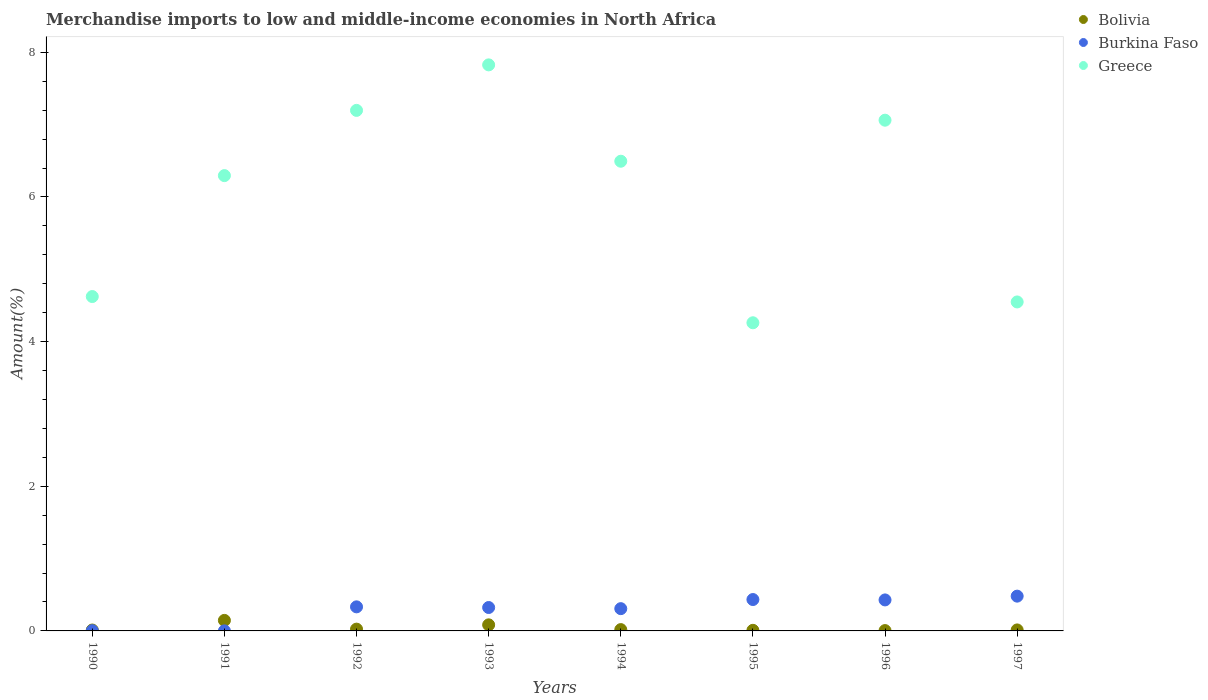How many different coloured dotlines are there?
Your answer should be compact. 3. What is the percentage of amount earned from merchandise imports in Burkina Faso in 1992?
Your answer should be compact. 0.33. Across all years, what is the maximum percentage of amount earned from merchandise imports in Bolivia?
Make the answer very short. 0.15. Across all years, what is the minimum percentage of amount earned from merchandise imports in Burkina Faso?
Make the answer very short. 0. In which year was the percentage of amount earned from merchandise imports in Burkina Faso maximum?
Offer a terse response. 1997. What is the total percentage of amount earned from merchandise imports in Burkina Faso in the graph?
Offer a terse response. 2.31. What is the difference between the percentage of amount earned from merchandise imports in Greece in 1994 and that in 1997?
Your response must be concise. 1.95. What is the difference between the percentage of amount earned from merchandise imports in Burkina Faso in 1992 and the percentage of amount earned from merchandise imports in Greece in 1997?
Give a very brief answer. -4.22. What is the average percentage of amount earned from merchandise imports in Greece per year?
Offer a very short reply. 6.04. In the year 1990, what is the difference between the percentage of amount earned from merchandise imports in Greece and percentage of amount earned from merchandise imports in Bolivia?
Give a very brief answer. 4.61. In how many years, is the percentage of amount earned from merchandise imports in Burkina Faso greater than 4.8 %?
Provide a succinct answer. 0. What is the ratio of the percentage of amount earned from merchandise imports in Bolivia in 1991 to that in 1996?
Your answer should be very brief. 30.61. Is the percentage of amount earned from merchandise imports in Greece in 1996 less than that in 1997?
Your answer should be very brief. No. Is the difference between the percentage of amount earned from merchandise imports in Greece in 1990 and 1997 greater than the difference between the percentage of amount earned from merchandise imports in Bolivia in 1990 and 1997?
Provide a short and direct response. Yes. What is the difference between the highest and the second highest percentage of amount earned from merchandise imports in Burkina Faso?
Provide a succinct answer. 0.05. What is the difference between the highest and the lowest percentage of amount earned from merchandise imports in Burkina Faso?
Provide a short and direct response. 0.48. Does the percentage of amount earned from merchandise imports in Greece monotonically increase over the years?
Your answer should be very brief. No. Is the percentage of amount earned from merchandise imports in Greece strictly greater than the percentage of amount earned from merchandise imports in Burkina Faso over the years?
Give a very brief answer. Yes. How many dotlines are there?
Provide a short and direct response. 3. How many years are there in the graph?
Ensure brevity in your answer.  8. Are the values on the major ticks of Y-axis written in scientific E-notation?
Offer a terse response. No. Does the graph contain any zero values?
Provide a succinct answer. No. Where does the legend appear in the graph?
Offer a terse response. Top right. How are the legend labels stacked?
Your answer should be compact. Vertical. What is the title of the graph?
Your answer should be very brief. Merchandise imports to low and middle-income economies in North Africa. What is the label or title of the Y-axis?
Your answer should be compact. Amount(%). What is the Amount(%) of Bolivia in 1990?
Offer a terse response. 0.01. What is the Amount(%) of Burkina Faso in 1990?
Keep it short and to the point. 0. What is the Amount(%) in Greece in 1990?
Offer a terse response. 4.62. What is the Amount(%) of Bolivia in 1991?
Keep it short and to the point. 0.15. What is the Amount(%) of Burkina Faso in 1991?
Provide a short and direct response. 0. What is the Amount(%) in Greece in 1991?
Your answer should be compact. 6.3. What is the Amount(%) of Bolivia in 1992?
Your response must be concise. 0.02. What is the Amount(%) in Burkina Faso in 1992?
Provide a short and direct response. 0.33. What is the Amount(%) in Greece in 1992?
Provide a succinct answer. 7.2. What is the Amount(%) in Bolivia in 1993?
Offer a very short reply. 0.08. What is the Amount(%) of Burkina Faso in 1993?
Your answer should be compact. 0.32. What is the Amount(%) of Greece in 1993?
Offer a very short reply. 7.83. What is the Amount(%) of Bolivia in 1994?
Offer a terse response. 0.02. What is the Amount(%) of Burkina Faso in 1994?
Offer a very short reply. 0.31. What is the Amount(%) in Greece in 1994?
Give a very brief answer. 6.49. What is the Amount(%) of Bolivia in 1995?
Ensure brevity in your answer.  0.01. What is the Amount(%) in Burkina Faso in 1995?
Make the answer very short. 0.43. What is the Amount(%) in Greece in 1995?
Make the answer very short. 4.26. What is the Amount(%) in Bolivia in 1996?
Keep it short and to the point. 0. What is the Amount(%) of Burkina Faso in 1996?
Provide a succinct answer. 0.43. What is the Amount(%) of Greece in 1996?
Provide a short and direct response. 7.06. What is the Amount(%) of Bolivia in 1997?
Provide a short and direct response. 0.01. What is the Amount(%) in Burkina Faso in 1997?
Offer a very short reply. 0.48. What is the Amount(%) in Greece in 1997?
Your answer should be compact. 4.55. Across all years, what is the maximum Amount(%) in Bolivia?
Your answer should be compact. 0.15. Across all years, what is the maximum Amount(%) of Burkina Faso?
Provide a succinct answer. 0.48. Across all years, what is the maximum Amount(%) of Greece?
Give a very brief answer. 7.83. Across all years, what is the minimum Amount(%) in Bolivia?
Keep it short and to the point. 0. Across all years, what is the minimum Amount(%) in Burkina Faso?
Your response must be concise. 0. Across all years, what is the minimum Amount(%) in Greece?
Provide a short and direct response. 4.26. What is the total Amount(%) in Bolivia in the graph?
Your response must be concise. 0.31. What is the total Amount(%) in Burkina Faso in the graph?
Provide a short and direct response. 2.31. What is the total Amount(%) in Greece in the graph?
Offer a terse response. 48.31. What is the difference between the Amount(%) of Bolivia in 1990 and that in 1991?
Offer a terse response. -0.13. What is the difference between the Amount(%) of Burkina Faso in 1990 and that in 1991?
Make the answer very short. 0. What is the difference between the Amount(%) of Greece in 1990 and that in 1991?
Provide a succinct answer. -1.67. What is the difference between the Amount(%) in Bolivia in 1990 and that in 1992?
Provide a short and direct response. -0.01. What is the difference between the Amount(%) of Burkina Faso in 1990 and that in 1992?
Your response must be concise. -0.33. What is the difference between the Amount(%) of Greece in 1990 and that in 1992?
Your answer should be very brief. -2.57. What is the difference between the Amount(%) of Bolivia in 1990 and that in 1993?
Keep it short and to the point. -0.07. What is the difference between the Amount(%) in Burkina Faso in 1990 and that in 1993?
Your answer should be very brief. -0.32. What is the difference between the Amount(%) of Greece in 1990 and that in 1993?
Keep it short and to the point. -3.2. What is the difference between the Amount(%) of Bolivia in 1990 and that in 1994?
Offer a very short reply. -0.01. What is the difference between the Amount(%) in Burkina Faso in 1990 and that in 1994?
Your answer should be very brief. -0.3. What is the difference between the Amount(%) of Greece in 1990 and that in 1994?
Make the answer very short. -1.87. What is the difference between the Amount(%) of Bolivia in 1990 and that in 1995?
Your answer should be very brief. 0. What is the difference between the Amount(%) in Burkina Faso in 1990 and that in 1995?
Your answer should be very brief. -0.43. What is the difference between the Amount(%) in Greece in 1990 and that in 1995?
Your answer should be very brief. 0.36. What is the difference between the Amount(%) in Bolivia in 1990 and that in 1996?
Provide a short and direct response. 0.01. What is the difference between the Amount(%) in Burkina Faso in 1990 and that in 1996?
Provide a short and direct response. -0.43. What is the difference between the Amount(%) in Greece in 1990 and that in 1996?
Your answer should be compact. -2.44. What is the difference between the Amount(%) in Bolivia in 1990 and that in 1997?
Keep it short and to the point. -0. What is the difference between the Amount(%) of Burkina Faso in 1990 and that in 1997?
Provide a short and direct response. -0.48. What is the difference between the Amount(%) of Greece in 1990 and that in 1997?
Offer a terse response. 0.07. What is the difference between the Amount(%) of Bolivia in 1991 and that in 1992?
Your answer should be very brief. 0.12. What is the difference between the Amount(%) in Burkina Faso in 1991 and that in 1992?
Offer a terse response. -0.33. What is the difference between the Amount(%) of Greece in 1991 and that in 1992?
Keep it short and to the point. -0.9. What is the difference between the Amount(%) of Bolivia in 1991 and that in 1993?
Your response must be concise. 0.06. What is the difference between the Amount(%) in Burkina Faso in 1991 and that in 1993?
Your answer should be compact. -0.32. What is the difference between the Amount(%) in Greece in 1991 and that in 1993?
Your answer should be very brief. -1.53. What is the difference between the Amount(%) in Bolivia in 1991 and that in 1994?
Your response must be concise. 0.13. What is the difference between the Amount(%) of Burkina Faso in 1991 and that in 1994?
Offer a very short reply. -0.31. What is the difference between the Amount(%) of Greece in 1991 and that in 1994?
Provide a short and direct response. -0.2. What is the difference between the Amount(%) in Bolivia in 1991 and that in 1995?
Keep it short and to the point. 0.14. What is the difference between the Amount(%) in Burkina Faso in 1991 and that in 1995?
Offer a very short reply. -0.43. What is the difference between the Amount(%) of Greece in 1991 and that in 1995?
Ensure brevity in your answer.  2.03. What is the difference between the Amount(%) in Bolivia in 1991 and that in 1996?
Keep it short and to the point. 0.14. What is the difference between the Amount(%) in Burkina Faso in 1991 and that in 1996?
Offer a very short reply. -0.43. What is the difference between the Amount(%) in Greece in 1991 and that in 1996?
Provide a succinct answer. -0.77. What is the difference between the Amount(%) in Bolivia in 1991 and that in 1997?
Your answer should be very brief. 0.13. What is the difference between the Amount(%) in Burkina Faso in 1991 and that in 1997?
Your response must be concise. -0.48. What is the difference between the Amount(%) of Greece in 1991 and that in 1997?
Offer a terse response. 1.75. What is the difference between the Amount(%) in Bolivia in 1992 and that in 1993?
Offer a terse response. -0.06. What is the difference between the Amount(%) in Burkina Faso in 1992 and that in 1993?
Offer a terse response. 0.01. What is the difference between the Amount(%) of Greece in 1992 and that in 1993?
Give a very brief answer. -0.63. What is the difference between the Amount(%) of Bolivia in 1992 and that in 1994?
Offer a terse response. 0.01. What is the difference between the Amount(%) in Burkina Faso in 1992 and that in 1994?
Your answer should be very brief. 0.02. What is the difference between the Amount(%) in Greece in 1992 and that in 1994?
Make the answer very short. 0.7. What is the difference between the Amount(%) of Bolivia in 1992 and that in 1995?
Give a very brief answer. 0.02. What is the difference between the Amount(%) of Burkina Faso in 1992 and that in 1995?
Your response must be concise. -0.1. What is the difference between the Amount(%) of Greece in 1992 and that in 1995?
Offer a very short reply. 2.94. What is the difference between the Amount(%) in Burkina Faso in 1992 and that in 1996?
Your response must be concise. -0.1. What is the difference between the Amount(%) of Greece in 1992 and that in 1996?
Your response must be concise. 0.14. What is the difference between the Amount(%) of Bolivia in 1992 and that in 1997?
Provide a succinct answer. 0.01. What is the difference between the Amount(%) of Burkina Faso in 1992 and that in 1997?
Give a very brief answer. -0.15. What is the difference between the Amount(%) in Greece in 1992 and that in 1997?
Offer a very short reply. 2.65. What is the difference between the Amount(%) of Bolivia in 1993 and that in 1994?
Keep it short and to the point. 0.07. What is the difference between the Amount(%) of Burkina Faso in 1993 and that in 1994?
Offer a very short reply. 0.02. What is the difference between the Amount(%) in Greece in 1993 and that in 1994?
Offer a very short reply. 1.33. What is the difference between the Amount(%) in Bolivia in 1993 and that in 1995?
Provide a short and direct response. 0.08. What is the difference between the Amount(%) of Burkina Faso in 1993 and that in 1995?
Make the answer very short. -0.11. What is the difference between the Amount(%) in Greece in 1993 and that in 1995?
Give a very brief answer. 3.57. What is the difference between the Amount(%) of Bolivia in 1993 and that in 1996?
Give a very brief answer. 0.08. What is the difference between the Amount(%) in Burkina Faso in 1993 and that in 1996?
Your response must be concise. -0.1. What is the difference between the Amount(%) of Greece in 1993 and that in 1996?
Give a very brief answer. 0.76. What is the difference between the Amount(%) of Bolivia in 1993 and that in 1997?
Ensure brevity in your answer.  0.07. What is the difference between the Amount(%) in Burkina Faso in 1993 and that in 1997?
Keep it short and to the point. -0.16. What is the difference between the Amount(%) in Greece in 1993 and that in 1997?
Your response must be concise. 3.28. What is the difference between the Amount(%) in Bolivia in 1994 and that in 1995?
Your response must be concise. 0.01. What is the difference between the Amount(%) in Burkina Faso in 1994 and that in 1995?
Give a very brief answer. -0.13. What is the difference between the Amount(%) of Greece in 1994 and that in 1995?
Give a very brief answer. 2.23. What is the difference between the Amount(%) in Bolivia in 1994 and that in 1996?
Provide a succinct answer. 0.01. What is the difference between the Amount(%) of Burkina Faso in 1994 and that in 1996?
Provide a succinct answer. -0.12. What is the difference between the Amount(%) in Greece in 1994 and that in 1996?
Provide a short and direct response. -0.57. What is the difference between the Amount(%) in Bolivia in 1994 and that in 1997?
Keep it short and to the point. 0. What is the difference between the Amount(%) in Burkina Faso in 1994 and that in 1997?
Offer a terse response. -0.17. What is the difference between the Amount(%) of Greece in 1994 and that in 1997?
Your answer should be compact. 1.95. What is the difference between the Amount(%) of Bolivia in 1995 and that in 1996?
Offer a terse response. 0. What is the difference between the Amount(%) of Burkina Faso in 1995 and that in 1996?
Your answer should be compact. 0.01. What is the difference between the Amount(%) in Greece in 1995 and that in 1996?
Offer a very short reply. -2.8. What is the difference between the Amount(%) in Bolivia in 1995 and that in 1997?
Make the answer very short. -0.01. What is the difference between the Amount(%) in Burkina Faso in 1995 and that in 1997?
Your response must be concise. -0.05. What is the difference between the Amount(%) of Greece in 1995 and that in 1997?
Keep it short and to the point. -0.29. What is the difference between the Amount(%) in Bolivia in 1996 and that in 1997?
Your response must be concise. -0.01. What is the difference between the Amount(%) in Burkina Faso in 1996 and that in 1997?
Your answer should be very brief. -0.05. What is the difference between the Amount(%) in Greece in 1996 and that in 1997?
Provide a short and direct response. 2.51. What is the difference between the Amount(%) in Bolivia in 1990 and the Amount(%) in Burkina Faso in 1991?
Provide a short and direct response. 0.01. What is the difference between the Amount(%) of Bolivia in 1990 and the Amount(%) of Greece in 1991?
Offer a very short reply. -6.28. What is the difference between the Amount(%) in Burkina Faso in 1990 and the Amount(%) in Greece in 1991?
Provide a succinct answer. -6.29. What is the difference between the Amount(%) of Bolivia in 1990 and the Amount(%) of Burkina Faso in 1992?
Your answer should be very brief. -0.32. What is the difference between the Amount(%) in Bolivia in 1990 and the Amount(%) in Greece in 1992?
Provide a short and direct response. -7.18. What is the difference between the Amount(%) in Burkina Faso in 1990 and the Amount(%) in Greece in 1992?
Your answer should be compact. -7.19. What is the difference between the Amount(%) of Bolivia in 1990 and the Amount(%) of Burkina Faso in 1993?
Make the answer very short. -0.31. What is the difference between the Amount(%) in Bolivia in 1990 and the Amount(%) in Greece in 1993?
Ensure brevity in your answer.  -7.81. What is the difference between the Amount(%) in Burkina Faso in 1990 and the Amount(%) in Greece in 1993?
Provide a short and direct response. -7.82. What is the difference between the Amount(%) of Bolivia in 1990 and the Amount(%) of Burkina Faso in 1994?
Your answer should be compact. -0.3. What is the difference between the Amount(%) in Bolivia in 1990 and the Amount(%) in Greece in 1994?
Your response must be concise. -6.48. What is the difference between the Amount(%) in Burkina Faso in 1990 and the Amount(%) in Greece in 1994?
Provide a succinct answer. -6.49. What is the difference between the Amount(%) of Bolivia in 1990 and the Amount(%) of Burkina Faso in 1995?
Provide a succinct answer. -0.42. What is the difference between the Amount(%) of Bolivia in 1990 and the Amount(%) of Greece in 1995?
Make the answer very short. -4.25. What is the difference between the Amount(%) of Burkina Faso in 1990 and the Amount(%) of Greece in 1995?
Give a very brief answer. -4.26. What is the difference between the Amount(%) in Bolivia in 1990 and the Amount(%) in Burkina Faso in 1996?
Offer a terse response. -0.42. What is the difference between the Amount(%) of Bolivia in 1990 and the Amount(%) of Greece in 1996?
Offer a terse response. -7.05. What is the difference between the Amount(%) of Burkina Faso in 1990 and the Amount(%) of Greece in 1996?
Keep it short and to the point. -7.06. What is the difference between the Amount(%) in Bolivia in 1990 and the Amount(%) in Burkina Faso in 1997?
Give a very brief answer. -0.47. What is the difference between the Amount(%) in Bolivia in 1990 and the Amount(%) in Greece in 1997?
Offer a terse response. -4.54. What is the difference between the Amount(%) in Burkina Faso in 1990 and the Amount(%) in Greece in 1997?
Offer a very short reply. -4.54. What is the difference between the Amount(%) in Bolivia in 1991 and the Amount(%) in Burkina Faso in 1992?
Offer a terse response. -0.19. What is the difference between the Amount(%) of Bolivia in 1991 and the Amount(%) of Greece in 1992?
Your response must be concise. -7.05. What is the difference between the Amount(%) in Burkina Faso in 1991 and the Amount(%) in Greece in 1992?
Make the answer very short. -7.2. What is the difference between the Amount(%) in Bolivia in 1991 and the Amount(%) in Burkina Faso in 1993?
Offer a terse response. -0.18. What is the difference between the Amount(%) of Bolivia in 1991 and the Amount(%) of Greece in 1993?
Keep it short and to the point. -7.68. What is the difference between the Amount(%) of Burkina Faso in 1991 and the Amount(%) of Greece in 1993?
Give a very brief answer. -7.83. What is the difference between the Amount(%) of Bolivia in 1991 and the Amount(%) of Burkina Faso in 1994?
Provide a short and direct response. -0.16. What is the difference between the Amount(%) of Bolivia in 1991 and the Amount(%) of Greece in 1994?
Provide a short and direct response. -6.35. What is the difference between the Amount(%) of Burkina Faso in 1991 and the Amount(%) of Greece in 1994?
Make the answer very short. -6.49. What is the difference between the Amount(%) in Bolivia in 1991 and the Amount(%) in Burkina Faso in 1995?
Offer a terse response. -0.29. What is the difference between the Amount(%) of Bolivia in 1991 and the Amount(%) of Greece in 1995?
Offer a terse response. -4.12. What is the difference between the Amount(%) of Burkina Faso in 1991 and the Amount(%) of Greece in 1995?
Offer a terse response. -4.26. What is the difference between the Amount(%) in Bolivia in 1991 and the Amount(%) in Burkina Faso in 1996?
Your response must be concise. -0.28. What is the difference between the Amount(%) of Bolivia in 1991 and the Amount(%) of Greece in 1996?
Your answer should be compact. -6.92. What is the difference between the Amount(%) of Burkina Faso in 1991 and the Amount(%) of Greece in 1996?
Make the answer very short. -7.06. What is the difference between the Amount(%) in Bolivia in 1991 and the Amount(%) in Burkina Faso in 1997?
Give a very brief answer. -0.34. What is the difference between the Amount(%) in Bolivia in 1991 and the Amount(%) in Greece in 1997?
Keep it short and to the point. -4.4. What is the difference between the Amount(%) in Burkina Faso in 1991 and the Amount(%) in Greece in 1997?
Your response must be concise. -4.55. What is the difference between the Amount(%) of Bolivia in 1992 and the Amount(%) of Burkina Faso in 1993?
Your answer should be compact. -0.3. What is the difference between the Amount(%) of Bolivia in 1992 and the Amount(%) of Greece in 1993?
Your answer should be compact. -7.8. What is the difference between the Amount(%) in Burkina Faso in 1992 and the Amount(%) in Greece in 1993?
Your response must be concise. -7.49. What is the difference between the Amount(%) of Bolivia in 1992 and the Amount(%) of Burkina Faso in 1994?
Your response must be concise. -0.28. What is the difference between the Amount(%) in Bolivia in 1992 and the Amount(%) in Greece in 1994?
Give a very brief answer. -6.47. What is the difference between the Amount(%) in Burkina Faso in 1992 and the Amount(%) in Greece in 1994?
Make the answer very short. -6.16. What is the difference between the Amount(%) in Bolivia in 1992 and the Amount(%) in Burkina Faso in 1995?
Give a very brief answer. -0.41. What is the difference between the Amount(%) in Bolivia in 1992 and the Amount(%) in Greece in 1995?
Make the answer very short. -4.24. What is the difference between the Amount(%) in Burkina Faso in 1992 and the Amount(%) in Greece in 1995?
Ensure brevity in your answer.  -3.93. What is the difference between the Amount(%) in Bolivia in 1992 and the Amount(%) in Burkina Faso in 1996?
Provide a succinct answer. -0.4. What is the difference between the Amount(%) of Bolivia in 1992 and the Amount(%) of Greece in 1996?
Your answer should be compact. -7.04. What is the difference between the Amount(%) of Burkina Faso in 1992 and the Amount(%) of Greece in 1996?
Provide a succinct answer. -6.73. What is the difference between the Amount(%) of Bolivia in 1992 and the Amount(%) of Burkina Faso in 1997?
Make the answer very short. -0.46. What is the difference between the Amount(%) of Bolivia in 1992 and the Amount(%) of Greece in 1997?
Give a very brief answer. -4.52. What is the difference between the Amount(%) in Burkina Faso in 1992 and the Amount(%) in Greece in 1997?
Offer a terse response. -4.22. What is the difference between the Amount(%) of Bolivia in 1993 and the Amount(%) of Burkina Faso in 1994?
Ensure brevity in your answer.  -0.22. What is the difference between the Amount(%) of Bolivia in 1993 and the Amount(%) of Greece in 1994?
Your answer should be compact. -6.41. What is the difference between the Amount(%) in Burkina Faso in 1993 and the Amount(%) in Greece in 1994?
Provide a succinct answer. -6.17. What is the difference between the Amount(%) in Bolivia in 1993 and the Amount(%) in Burkina Faso in 1995?
Provide a short and direct response. -0.35. What is the difference between the Amount(%) in Bolivia in 1993 and the Amount(%) in Greece in 1995?
Ensure brevity in your answer.  -4.18. What is the difference between the Amount(%) of Burkina Faso in 1993 and the Amount(%) of Greece in 1995?
Your answer should be very brief. -3.94. What is the difference between the Amount(%) in Bolivia in 1993 and the Amount(%) in Burkina Faso in 1996?
Offer a terse response. -0.34. What is the difference between the Amount(%) of Bolivia in 1993 and the Amount(%) of Greece in 1996?
Your answer should be compact. -6.98. What is the difference between the Amount(%) of Burkina Faso in 1993 and the Amount(%) of Greece in 1996?
Your answer should be compact. -6.74. What is the difference between the Amount(%) in Bolivia in 1993 and the Amount(%) in Burkina Faso in 1997?
Keep it short and to the point. -0.4. What is the difference between the Amount(%) of Bolivia in 1993 and the Amount(%) of Greece in 1997?
Give a very brief answer. -4.46. What is the difference between the Amount(%) in Burkina Faso in 1993 and the Amount(%) in Greece in 1997?
Keep it short and to the point. -4.22. What is the difference between the Amount(%) of Bolivia in 1994 and the Amount(%) of Burkina Faso in 1995?
Your answer should be compact. -0.42. What is the difference between the Amount(%) of Bolivia in 1994 and the Amount(%) of Greece in 1995?
Keep it short and to the point. -4.24. What is the difference between the Amount(%) of Burkina Faso in 1994 and the Amount(%) of Greece in 1995?
Provide a succinct answer. -3.95. What is the difference between the Amount(%) of Bolivia in 1994 and the Amount(%) of Burkina Faso in 1996?
Your answer should be very brief. -0.41. What is the difference between the Amount(%) of Bolivia in 1994 and the Amount(%) of Greece in 1996?
Keep it short and to the point. -7.04. What is the difference between the Amount(%) of Burkina Faso in 1994 and the Amount(%) of Greece in 1996?
Provide a short and direct response. -6.75. What is the difference between the Amount(%) of Bolivia in 1994 and the Amount(%) of Burkina Faso in 1997?
Offer a terse response. -0.46. What is the difference between the Amount(%) of Bolivia in 1994 and the Amount(%) of Greece in 1997?
Offer a very short reply. -4.53. What is the difference between the Amount(%) of Burkina Faso in 1994 and the Amount(%) of Greece in 1997?
Your answer should be compact. -4.24. What is the difference between the Amount(%) in Bolivia in 1995 and the Amount(%) in Burkina Faso in 1996?
Provide a short and direct response. -0.42. What is the difference between the Amount(%) of Bolivia in 1995 and the Amount(%) of Greece in 1996?
Provide a succinct answer. -7.05. What is the difference between the Amount(%) in Burkina Faso in 1995 and the Amount(%) in Greece in 1996?
Your answer should be very brief. -6.63. What is the difference between the Amount(%) in Bolivia in 1995 and the Amount(%) in Burkina Faso in 1997?
Keep it short and to the point. -0.47. What is the difference between the Amount(%) in Bolivia in 1995 and the Amount(%) in Greece in 1997?
Your response must be concise. -4.54. What is the difference between the Amount(%) in Burkina Faso in 1995 and the Amount(%) in Greece in 1997?
Your response must be concise. -4.11. What is the difference between the Amount(%) in Bolivia in 1996 and the Amount(%) in Burkina Faso in 1997?
Give a very brief answer. -0.48. What is the difference between the Amount(%) in Bolivia in 1996 and the Amount(%) in Greece in 1997?
Offer a very short reply. -4.54. What is the difference between the Amount(%) of Burkina Faso in 1996 and the Amount(%) of Greece in 1997?
Offer a very short reply. -4.12. What is the average Amount(%) of Bolivia per year?
Provide a succinct answer. 0.04. What is the average Amount(%) in Burkina Faso per year?
Ensure brevity in your answer.  0.29. What is the average Amount(%) in Greece per year?
Keep it short and to the point. 6.04. In the year 1990, what is the difference between the Amount(%) of Bolivia and Amount(%) of Burkina Faso?
Your response must be concise. 0.01. In the year 1990, what is the difference between the Amount(%) in Bolivia and Amount(%) in Greece?
Offer a very short reply. -4.61. In the year 1990, what is the difference between the Amount(%) in Burkina Faso and Amount(%) in Greece?
Your response must be concise. -4.62. In the year 1991, what is the difference between the Amount(%) in Bolivia and Amount(%) in Burkina Faso?
Give a very brief answer. 0.14. In the year 1991, what is the difference between the Amount(%) in Bolivia and Amount(%) in Greece?
Keep it short and to the point. -6.15. In the year 1991, what is the difference between the Amount(%) of Burkina Faso and Amount(%) of Greece?
Offer a terse response. -6.29. In the year 1992, what is the difference between the Amount(%) in Bolivia and Amount(%) in Burkina Faso?
Offer a terse response. -0.31. In the year 1992, what is the difference between the Amount(%) of Bolivia and Amount(%) of Greece?
Ensure brevity in your answer.  -7.17. In the year 1992, what is the difference between the Amount(%) in Burkina Faso and Amount(%) in Greece?
Give a very brief answer. -6.86. In the year 1993, what is the difference between the Amount(%) in Bolivia and Amount(%) in Burkina Faso?
Keep it short and to the point. -0.24. In the year 1993, what is the difference between the Amount(%) in Bolivia and Amount(%) in Greece?
Provide a short and direct response. -7.74. In the year 1993, what is the difference between the Amount(%) of Burkina Faso and Amount(%) of Greece?
Your answer should be compact. -7.5. In the year 1994, what is the difference between the Amount(%) of Bolivia and Amount(%) of Burkina Faso?
Your response must be concise. -0.29. In the year 1994, what is the difference between the Amount(%) of Bolivia and Amount(%) of Greece?
Your response must be concise. -6.48. In the year 1994, what is the difference between the Amount(%) in Burkina Faso and Amount(%) in Greece?
Offer a very short reply. -6.19. In the year 1995, what is the difference between the Amount(%) in Bolivia and Amount(%) in Burkina Faso?
Ensure brevity in your answer.  -0.43. In the year 1995, what is the difference between the Amount(%) of Bolivia and Amount(%) of Greece?
Ensure brevity in your answer.  -4.25. In the year 1995, what is the difference between the Amount(%) of Burkina Faso and Amount(%) of Greece?
Offer a very short reply. -3.83. In the year 1996, what is the difference between the Amount(%) of Bolivia and Amount(%) of Burkina Faso?
Your response must be concise. -0.42. In the year 1996, what is the difference between the Amount(%) in Bolivia and Amount(%) in Greece?
Give a very brief answer. -7.06. In the year 1996, what is the difference between the Amount(%) in Burkina Faso and Amount(%) in Greece?
Keep it short and to the point. -6.63. In the year 1997, what is the difference between the Amount(%) of Bolivia and Amount(%) of Burkina Faso?
Make the answer very short. -0.47. In the year 1997, what is the difference between the Amount(%) of Bolivia and Amount(%) of Greece?
Make the answer very short. -4.53. In the year 1997, what is the difference between the Amount(%) of Burkina Faso and Amount(%) of Greece?
Your answer should be very brief. -4.07. What is the ratio of the Amount(%) of Bolivia in 1990 to that in 1991?
Give a very brief answer. 0.09. What is the ratio of the Amount(%) of Burkina Faso in 1990 to that in 1991?
Your response must be concise. 5.73. What is the ratio of the Amount(%) of Greece in 1990 to that in 1991?
Ensure brevity in your answer.  0.73. What is the ratio of the Amount(%) of Bolivia in 1990 to that in 1992?
Offer a terse response. 0.5. What is the ratio of the Amount(%) of Burkina Faso in 1990 to that in 1992?
Give a very brief answer. 0.01. What is the ratio of the Amount(%) in Greece in 1990 to that in 1992?
Your answer should be very brief. 0.64. What is the ratio of the Amount(%) in Bolivia in 1990 to that in 1993?
Your answer should be very brief. 0.15. What is the ratio of the Amount(%) of Burkina Faso in 1990 to that in 1993?
Provide a succinct answer. 0.01. What is the ratio of the Amount(%) of Greece in 1990 to that in 1993?
Offer a terse response. 0.59. What is the ratio of the Amount(%) of Bolivia in 1990 to that in 1994?
Make the answer very short. 0.68. What is the ratio of the Amount(%) in Burkina Faso in 1990 to that in 1994?
Offer a terse response. 0.01. What is the ratio of the Amount(%) in Greece in 1990 to that in 1994?
Make the answer very short. 0.71. What is the ratio of the Amount(%) of Bolivia in 1990 to that in 1995?
Your answer should be compact. 1.48. What is the ratio of the Amount(%) in Burkina Faso in 1990 to that in 1995?
Your answer should be very brief. 0.01. What is the ratio of the Amount(%) in Greece in 1990 to that in 1995?
Your answer should be compact. 1.09. What is the ratio of the Amount(%) of Bolivia in 1990 to that in 1996?
Make the answer very short. 2.62. What is the ratio of the Amount(%) of Burkina Faso in 1990 to that in 1996?
Offer a terse response. 0.01. What is the ratio of the Amount(%) in Greece in 1990 to that in 1996?
Keep it short and to the point. 0.65. What is the ratio of the Amount(%) of Bolivia in 1990 to that in 1997?
Offer a terse response. 0.91. What is the ratio of the Amount(%) of Burkina Faso in 1990 to that in 1997?
Provide a succinct answer. 0.01. What is the ratio of the Amount(%) of Greece in 1990 to that in 1997?
Keep it short and to the point. 1.02. What is the ratio of the Amount(%) in Bolivia in 1991 to that in 1992?
Offer a terse response. 5.88. What is the ratio of the Amount(%) in Burkina Faso in 1991 to that in 1992?
Provide a succinct answer. 0. What is the ratio of the Amount(%) of Greece in 1991 to that in 1992?
Your answer should be very brief. 0.87. What is the ratio of the Amount(%) in Bolivia in 1991 to that in 1993?
Your answer should be very brief. 1.73. What is the ratio of the Amount(%) of Burkina Faso in 1991 to that in 1993?
Keep it short and to the point. 0. What is the ratio of the Amount(%) in Greece in 1991 to that in 1993?
Provide a succinct answer. 0.8. What is the ratio of the Amount(%) in Bolivia in 1991 to that in 1994?
Ensure brevity in your answer.  7.97. What is the ratio of the Amount(%) in Burkina Faso in 1991 to that in 1994?
Offer a very short reply. 0. What is the ratio of the Amount(%) of Greece in 1991 to that in 1994?
Your response must be concise. 0.97. What is the ratio of the Amount(%) of Bolivia in 1991 to that in 1995?
Your answer should be very brief. 17.29. What is the ratio of the Amount(%) of Burkina Faso in 1991 to that in 1995?
Keep it short and to the point. 0. What is the ratio of the Amount(%) of Greece in 1991 to that in 1995?
Your answer should be very brief. 1.48. What is the ratio of the Amount(%) of Bolivia in 1991 to that in 1996?
Ensure brevity in your answer.  30.61. What is the ratio of the Amount(%) of Burkina Faso in 1991 to that in 1996?
Give a very brief answer. 0. What is the ratio of the Amount(%) of Greece in 1991 to that in 1996?
Give a very brief answer. 0.89. What is the ratio of the Amount(%) in Bolivia in 1991 to that in 1997?
Offer a terse response. 10.59. What is the ratio of the Amount(%) in Burkina Faso in 1991 to that in 1997?
Provide a succinct answer. 0. What is the ratio of the Amount(%) in Greece in 1991 to that in 1997?
Your answer should be compact. 1.38. What is the ratio of the Amount(%) in Bolivia in 1992 to that in 1993?
Provide a short and direct response. 0.3. What is the ratio of the Amount(%) in Burkina Faso in 1992 to that in 1993?
Your answer should be very brief. 1.03. What is the ratio of the Amount(%) of Greece in 1992 to that in 1993?
Offer a terse response. 0.92. What is the ratio of the Amount(%) of Bolivia in 1992 to that in 1994?
Ensure brevity in your answer.  1.36. What is the ratio of the Amount(%) of Burkina Faso in 1992 to that in 1994?
Ensure brevity in your answer.  1.08. What is the ratio of the Amount(%) of Greece in 1992 to that in 1994?
Offer a terse response. 1.11. What is the ratio of the Amount(%) of Bolivia in 1992 to that in 1995?
Your response must be concise. 2.94. What is the ratio of the Amount(%) of Burkina Faso in 1992 to that in 1995?
Give a very brief answer. 0.77. What is the ratio of the Amount(%) of Greece in 1992 to that in 1995?
Ensure brevity in your answer.  1.69. What is the ratio of the Amount(%) of Bolivia in 1992 to that in 1996?
Give a very brief answer. 5.21. What is the ratio of the Amount(%) in Burkina Faso in 1992 to that in 1996?
Offer a terse response. 0.78. What is the ratio of the Amount(%) of Greece in 1992 to that in 1996?
Provide a short and direct response. 1.02. What is the ratio of the Amount(%) in Bolivia in 1992 to that in 1997?
Your answer should be very brief. 1.8. What is the ratio of the Amount(%) in Burkina Faso in 1992 to that in 1997?
Your answer should be very brief. 0.69. What is the ratio of the Amount(%) in Greece in 1992 to that in 1997?
Your answer should be compact. 1.58. What is the ratio of the Amount(%) of Bolivia in 1993 to that in 1994?
Offer a very short reply. 4.6. What is the ratio of the Amount(%) of Burkina Faso in 1993 to that in 1994?
Give a very brief answer. 1.05. What is the ratio of the Amount(%) in Greece in 1993 to that in 1994?
Provide a succinct answer. 1.21. What is the ratio of the Amount(%) in Bolivia in 1993 to that in 1995?
Offer a terse response. 9.97. What is the ratio of the Amount(%) in Burkina Faso in 1993 to that in 1995?
Your answer should be very brief. 0.75. What is the ratio of the Amount(%) of Greece in 1993 to that in 1995?
Offer a terse response. 1.84. What is the ratio of the Amount(%) in Bolivia in 1993 to that in 1996?
Offer a terse response. 17.66. What is the ratio of the Amount(%) in Burkina Faso in 1993 to that in 1996?
Make the answer very short. 0.76. What is the ratio of the Amount(%) of Greece in 1993 to that in 1996?
Keep it short and to the point. 1.11. What is the ratio of the Amount(%) in Bolivia in 1993 to that in 1997?
Ensure brevity in your answer.  6.11. What is the ratio of the Amount(%) in Burkina Faso in 1993 to that in 1997?
Your answer should be compact. 0.67. What is the ratio of the Amount(%) of Greece in 1993 to that in 1997?
Offer a very short reply. 1.72. What is the ratio of the Amount(%) in Bolivia in 1994 to that in 1995?
Provide a short and direct response. 2.17. What is the ratio of the Amount(%) of Burkina Faso in 1994 to that in 1995?
Your answer should be very brief. 0.71. What is the ratio of the Amount(%) in Greece in 1994 to that in 1995?
Give a very brief answer. 1.52. What is the ratio of the Amount(%) of Bolivia in 1994 to that in 1996?
Make the answer very short. 3.84. What is the ratio of the Amount(%) of Burkina Faso in 1994 to that in 1996?
Keep it short and to the point. 0.72. What is the ratio of the Amount(%) in Greece in 1994 to that in 1996?
Offer a very short reply. 0.92. What is the ratio of the Amount(%) of Bolivia in 1994 to that in 1997?
Offer a very short reply. 1.33. What is the ratio of the Amount(%) in Burkina Faso in 1994 to that in 1997?
Your answer should be compact. 0.64. What is the ratio of the Amount(%) of Greece in 1994 to that in 1997?
Make the answer very short. 1.43. What is the ratio of the Amount(%) in Bolivia in 1995 to that in 1996?
Provide a succinct answer. 1.77. What is the ratio of the Amount(%) in Burkina Faso in 1995 to that in 1996?
Your answer should be compact. 1.01. What is the ratio of the Amount(%) of Greece in 1995 to that in 1996?
Your response must be concise. 0.6. What is the ratio of the Amount(%) in Bolivia in 1995 to that in 1997?
Keep it short and to the point. 0.61. What is the ratio of the Amount(%) of Burkina Faso in 1995 to that in 1997?
Offer a terse response. 0.9. What is the ratio of the Amount(%) of Greece in 1995 to that in 1997?
Keep it short and to the point. 0.94. What is the ratio of the Amount(%) of Bolivia in 1996 to that in 1997?
Offer a very short reply. 0.35. What is the ratio of the Amount(%) in Burkina Faso in 1996 to that in 1997?
Give a very brief answer. 0.89. What is the ratio of the Amount(%) of Greece in 1996 to that in 1997?
Make the answer very short. 1.55. What is the difference between the highest and the second highest Amount(%) of Bolivia?
Your response must be concise. 0.06. What is the difference between the highest and the second highest Amount(%) of Burkina Faso?
Offer a very short reply. 0.05. What is the difference between the highest and the second highest Amount(%) of Greece?
Your answer should be compact. 0.63. What is the difference between the highest and the lowest Amount(%) in Bolivia?
Offer a very short reply. 0.14. What is the difference between the highest and the lowest Amount(%) in Burkina Faso?
Provide a short and direct response. 0.48. What is the difference between the highest and the lowest Amount(%) of Greece?
Ensure brevity in your answer.  3.57. 